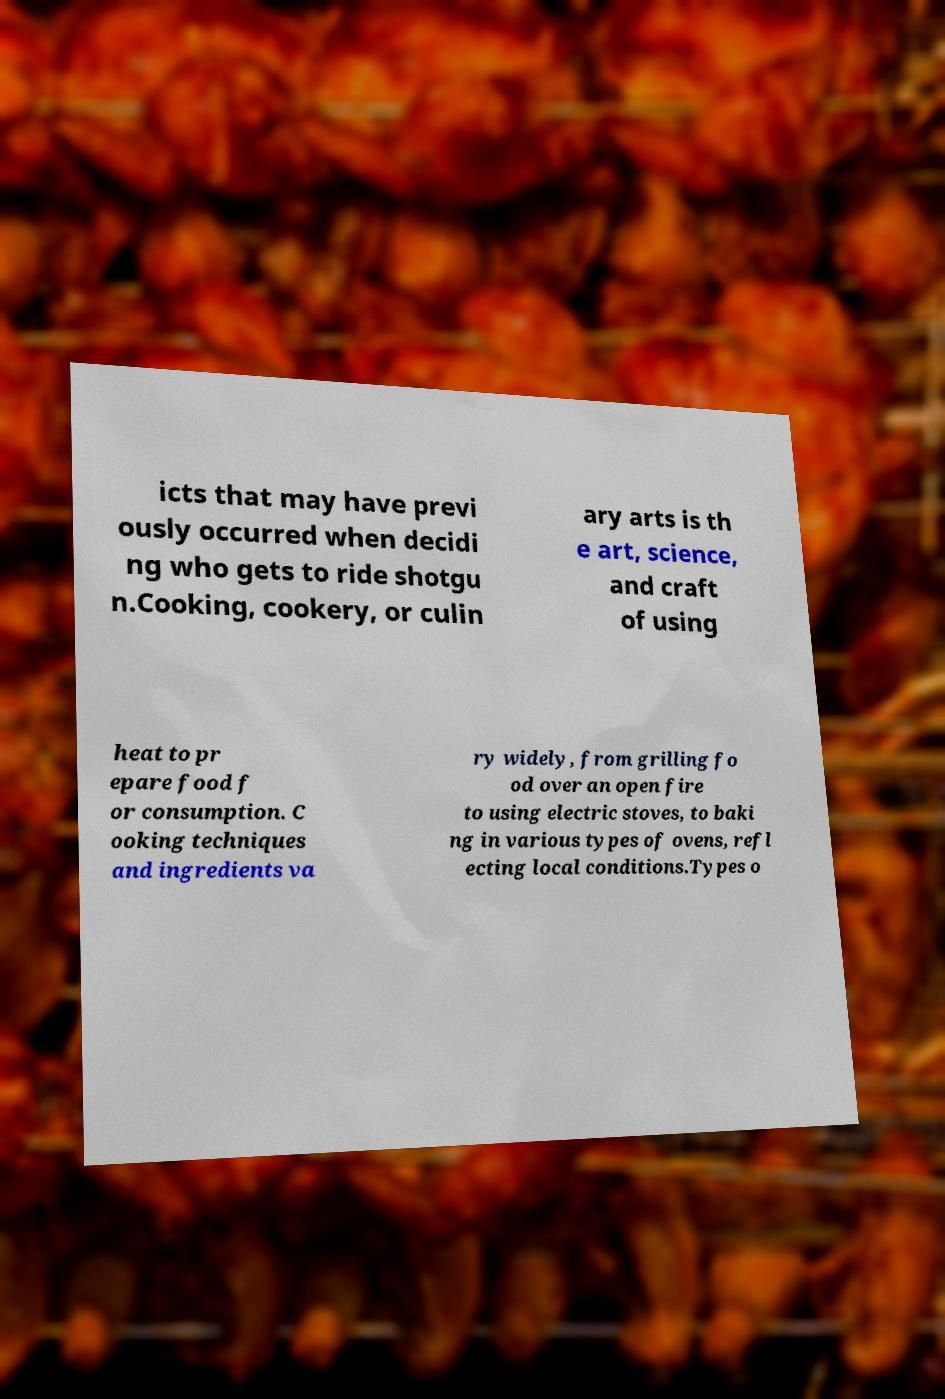Can you read and provide the text displayed in the image?This photo seems to have some interesting text. Can you extract and type it out for me? icts that may have previ ously occurred when decidi ng who gets to ride shotgu n.Cooking, cookery, or culin ary arts is th e art, science, and craft of using heat to pr epare food f or consumption. C ooking techniques and ingredients va ry widely, from grilling fo od over an open fire to using electric stoves, to baki ng in various types of ovens, refl ecting local conditions.Types o 